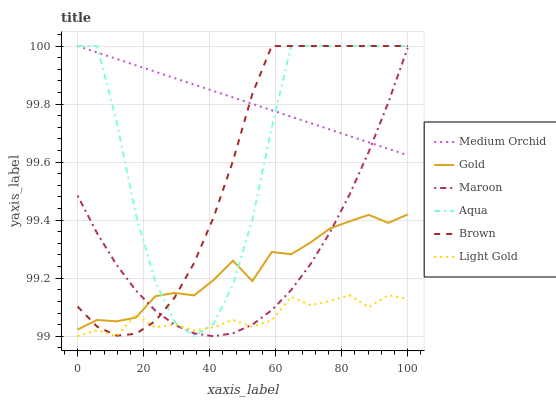Does Gold have the minimum area under the curve?
Answer yes or no. No. Does Gold have the maximum area under the curve?
Answer yes or no. No. Is Gold the smoothest?
Answer yes or no. No. Is Gold the roughest?
Answer yes or no. No. Does Gold have the lowest value?
Answer yes or no. No. Does Gold have the highest value?
Answer yes or no. No. Is Light Gold less than Medium Orchid?
Answer yes or no. Yes. Is Medium Orchid greater than Light Gold?
Answer yes or no. Yes. Does Light Gold intersect Medium Orchid?
Answer yes or no. No. 